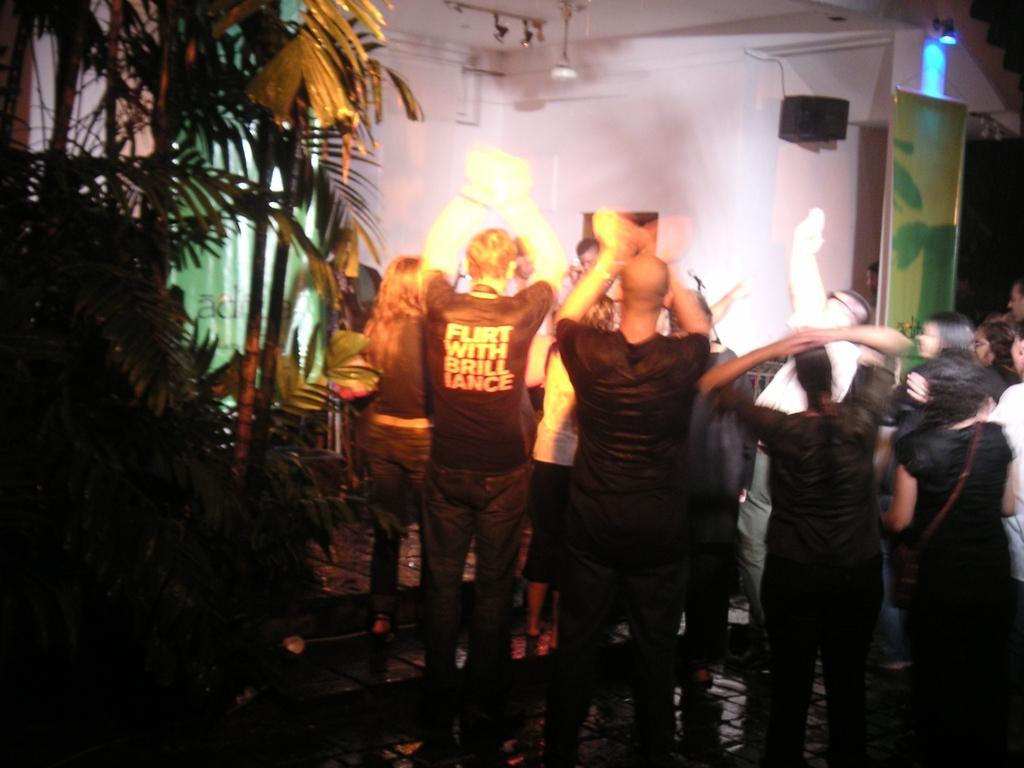What are the people in the image doing? The people in the image are dancing. What can be seen on the left side of the image? There are plants on the left side of the image. What is visible in the background of the image? There is a wall in the background of the image. What type of lighting is present in the image? There are lights on the ceiling in the image. Where is the speaker located in the image? The speaker is on a wall in the image. What type of needle is being used for treatment in the image? There is no needle or treatment present in the image; it features people dancing with plants, a wall, lights, and a speaker. 